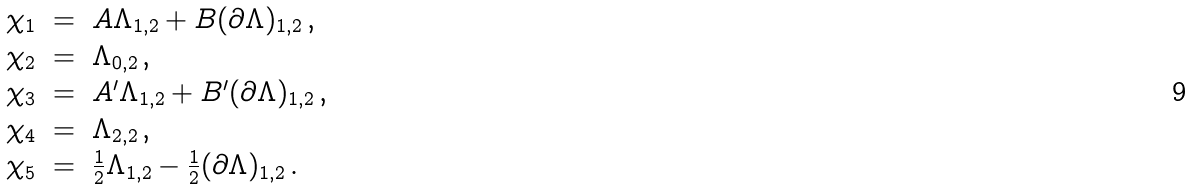<formula> <loc_0><loc_0><loc_500><loc_500>\begin{array} { r c l } { { \chi _ { 1 } } } & { = } & { { A \Lambda _ { 1 , 2 } + B ( \partial \Lambda ) _ { 1 , 2 } \, , } } \\ { { \chi _ { 2 } } } & { = } & { { \Lambda _ { 0 , 2 } \, , } } \\ { { \chi _ { 3 } } } & { = } & { { A ^ { \prime } \Lambda _ { 1 , 2 } + B ^ { \prime } ( \partial \Lambda ) _ { 1 , 2 } \, , } } \\ { { \chi _ { 4 } } } & { = } & { { \Lambda _ { 2 , 2 } \, , } } \\ { { \chi _ { 5 } } } & { = } & { { \frac { 1 } { 2 } \Lambda _ { 1 , 2 } - \frac { 1 } { 2 } ( \partial \Lambda ) _ { 1 , 2 } \, . } } \end{array}</formula> 